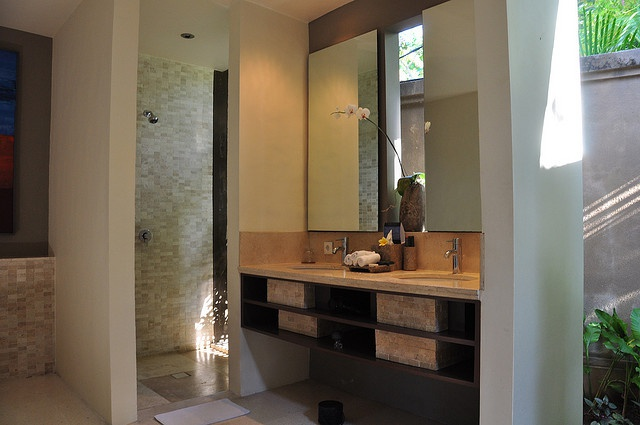Describe the objects in this image and their specific colors. I can see potted plant in gray, black, darkgreen, and green tones, sink in gray and brown tones, potted plant in gray, black, and tan tones, vase in gray, black, and darkgreen tones, and sink in gray, tan, and brown tones in this image. 